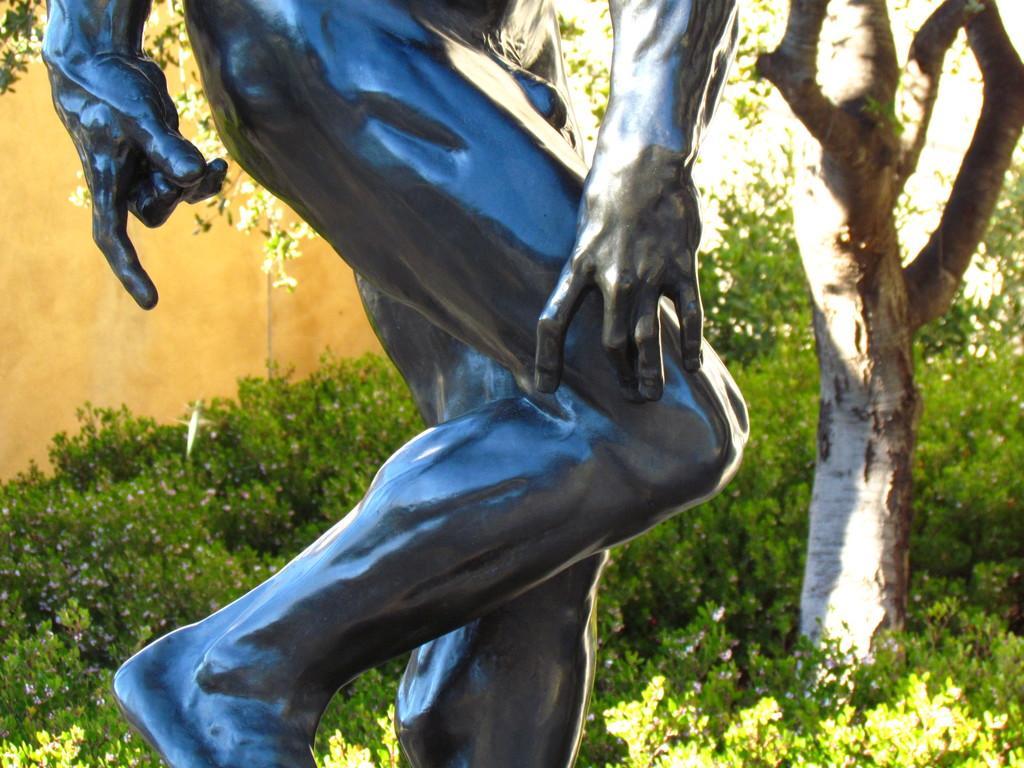Describe this image in one or two sentences. In this image we can see a sculpture, here are the small plants, here is the tree, here is the wall. 